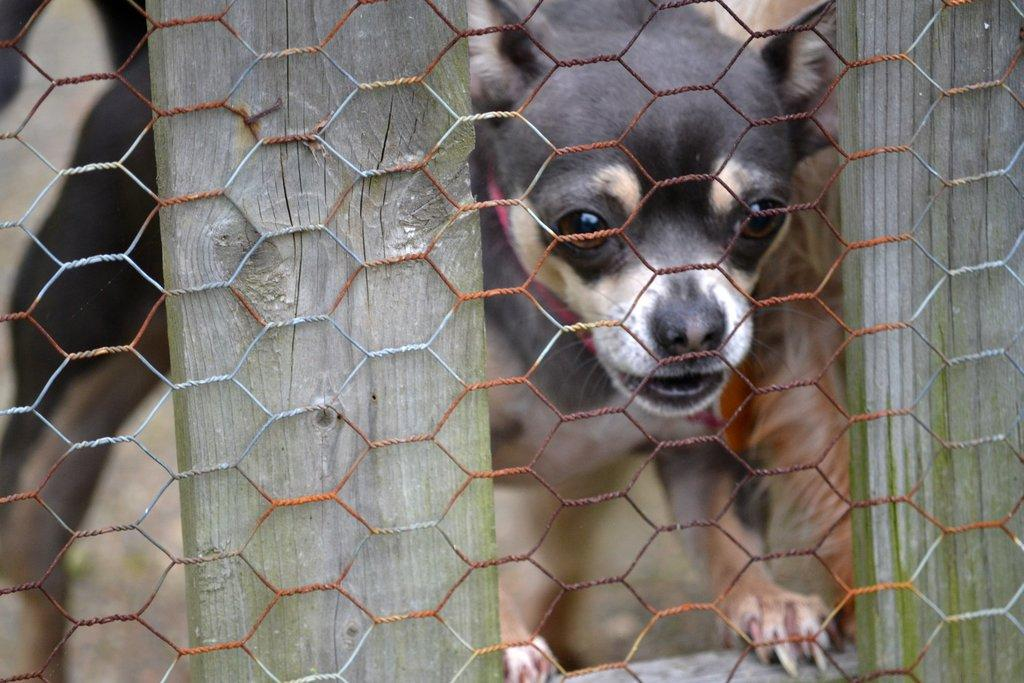What type of barrier is visible in the image? There is a net fencing in the image. What can be seen behind the fencing? There is a dog behind the fencing. What type of lift is present in the image? There is no lift present in the image; it only features a net fencing and a dog. What kind of paper can be seen in the image? There is no paper visible in the image. 